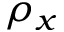<formula> <loc_0><loc_0><loc_500><loc_500>\rho _ { x }</formula> 